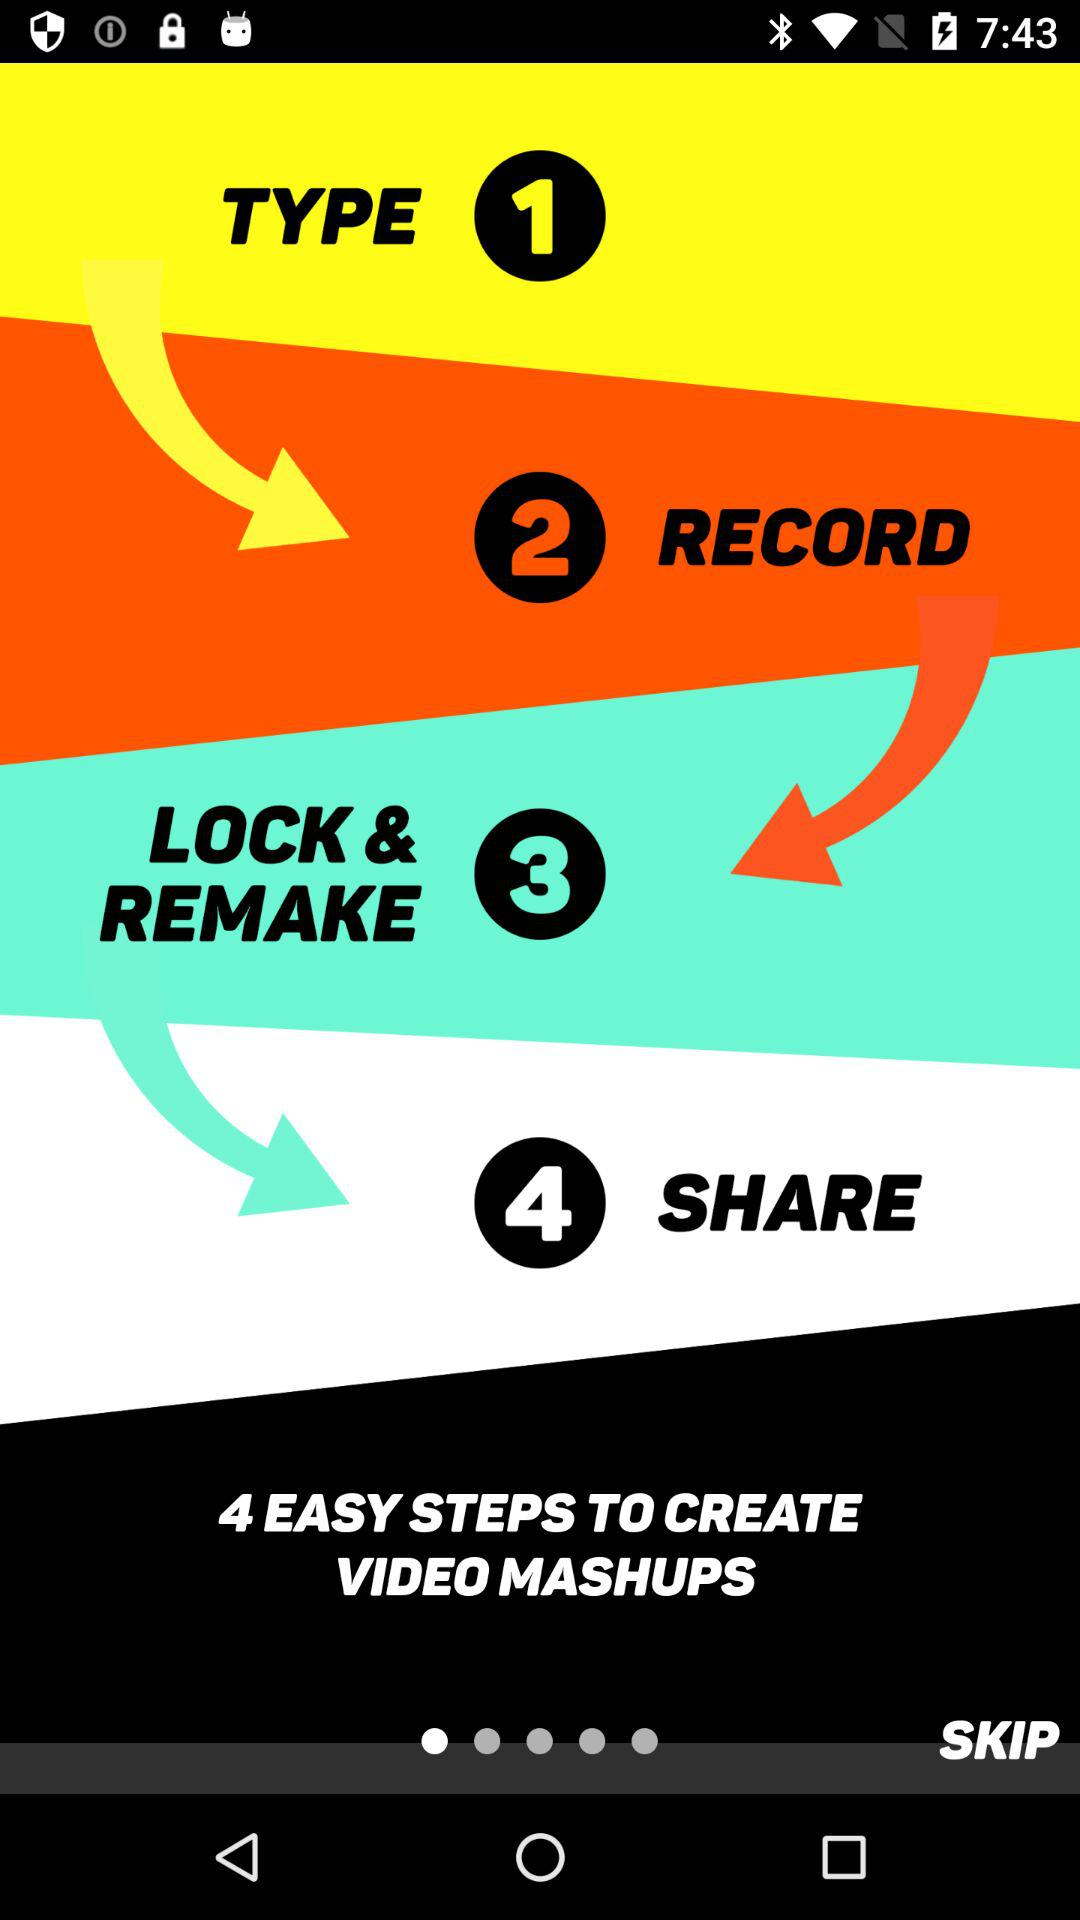How many steps are there in the process of creating a video mashup?
Answer the question using a single word or phrase. 4 